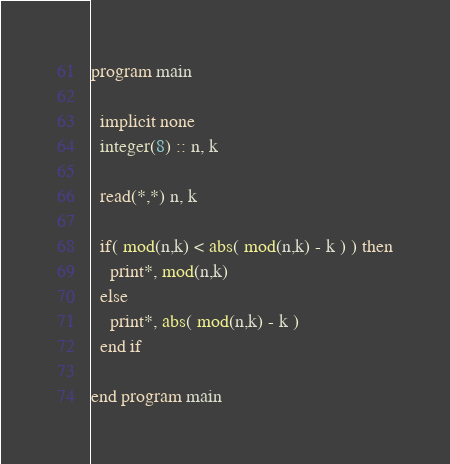Convert code to text. <code><loc_0><loc_0><loc_500><loc_500><_FORTRAN_>program main
  
  implicit none
  integer(8) :: n, k
  
  read(*,*) n, k
  
  if( mod(n,k) < abs( mod(n,k) - k ) ) then
    print*, mod(n,k) 
  else
    print*, abs( mod(n,k) - k )
  end if
  
end program main
</code> 